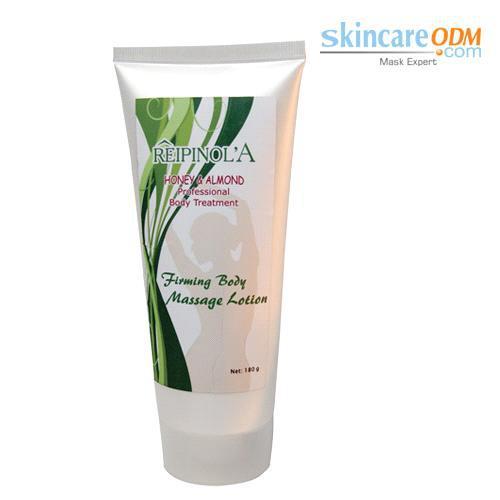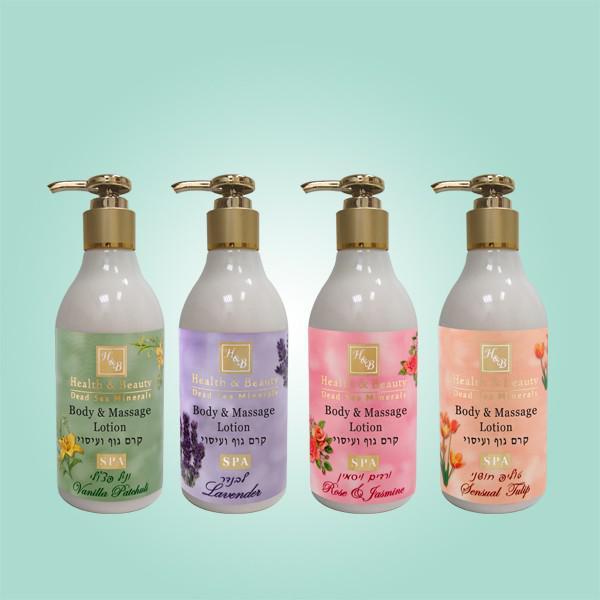The first image is the image on the left, the second image is the image on the right. Given the left and right images, does the statement "Each image contains one skincare product on white background." hold true? Answer yes or no. No. The first image is the image on the left, the second image is the image on the right. For the images shown, is this caption "At least one bottle of body lotion has a pump top." true? Answer yes or no. Yes. 